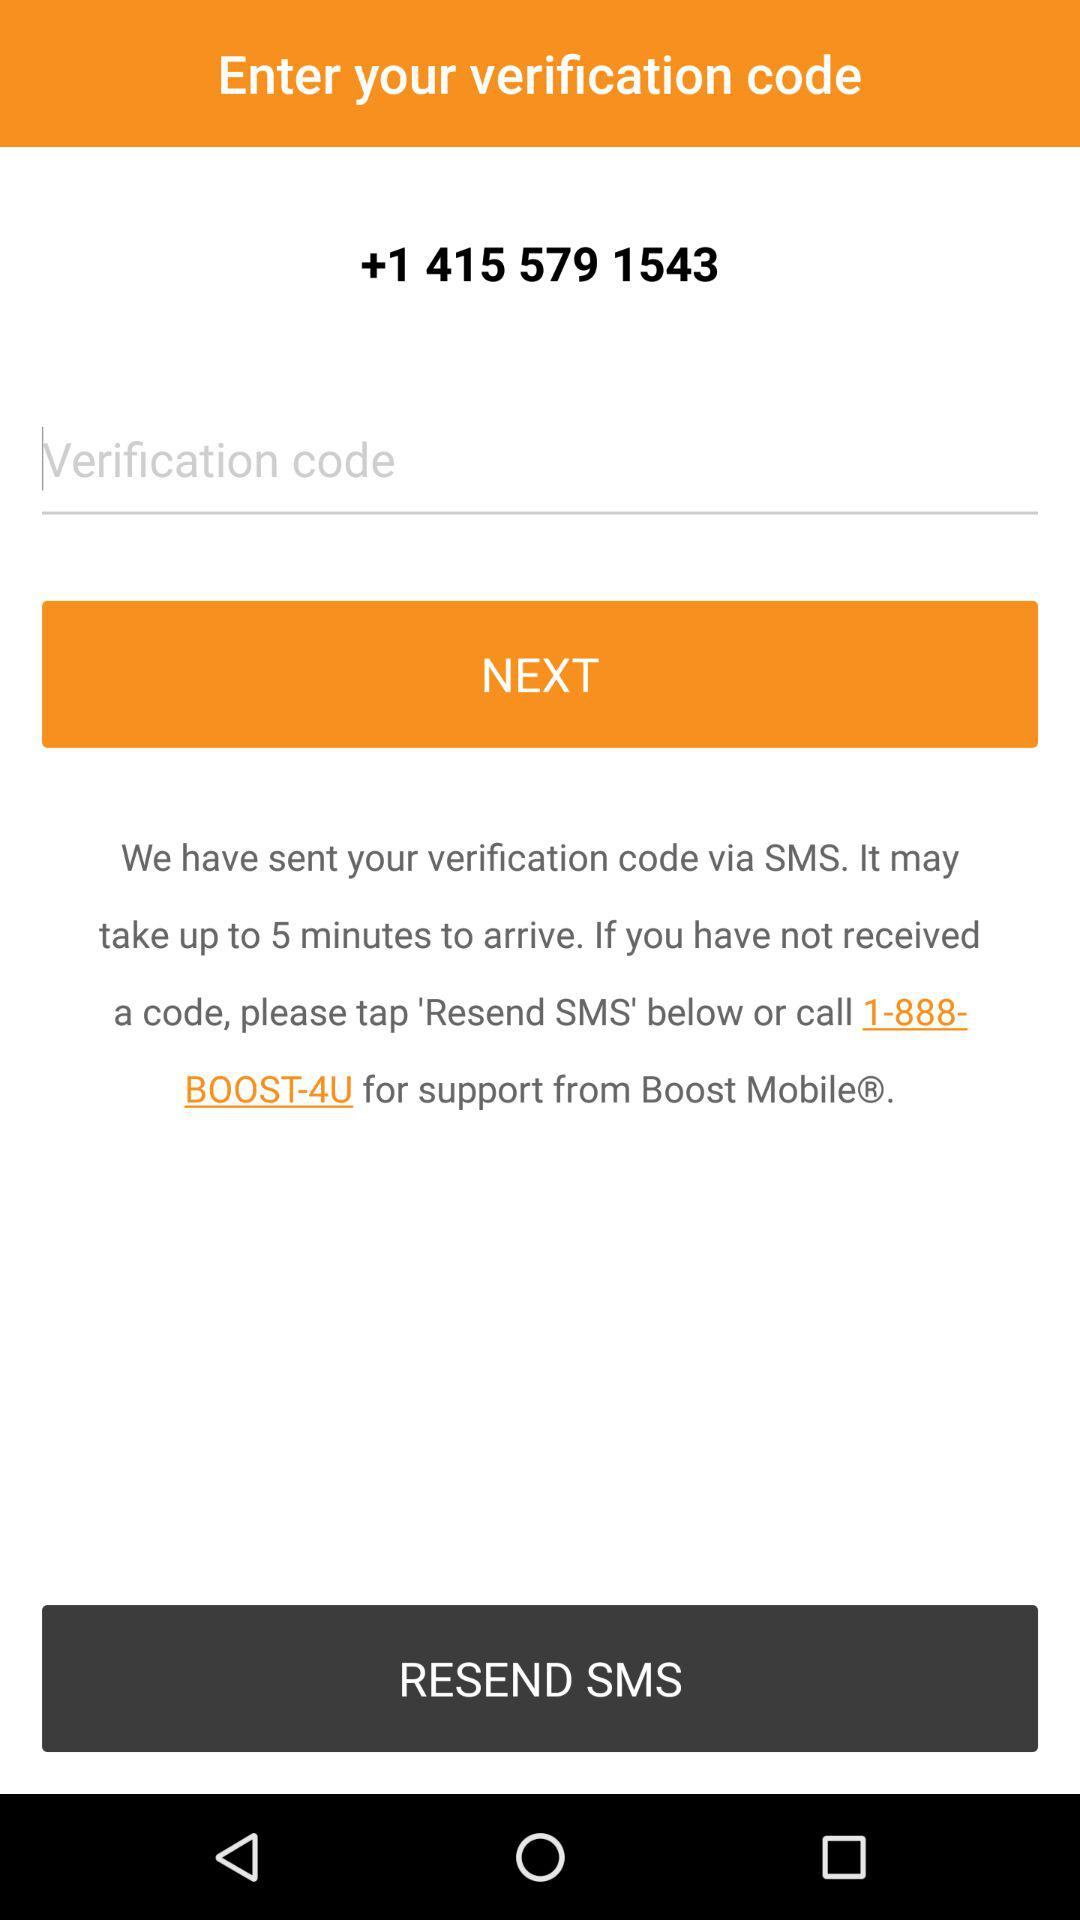On what number was the verification sent? The verification was sent to +1 415 579 1543. 